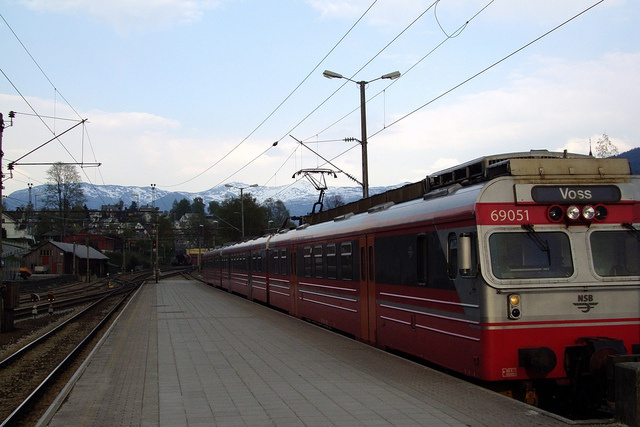Describe the objects in this image and their specific colors. I can see a train in lightblue, black, gray, maroon, and darkgray tones in this image. 